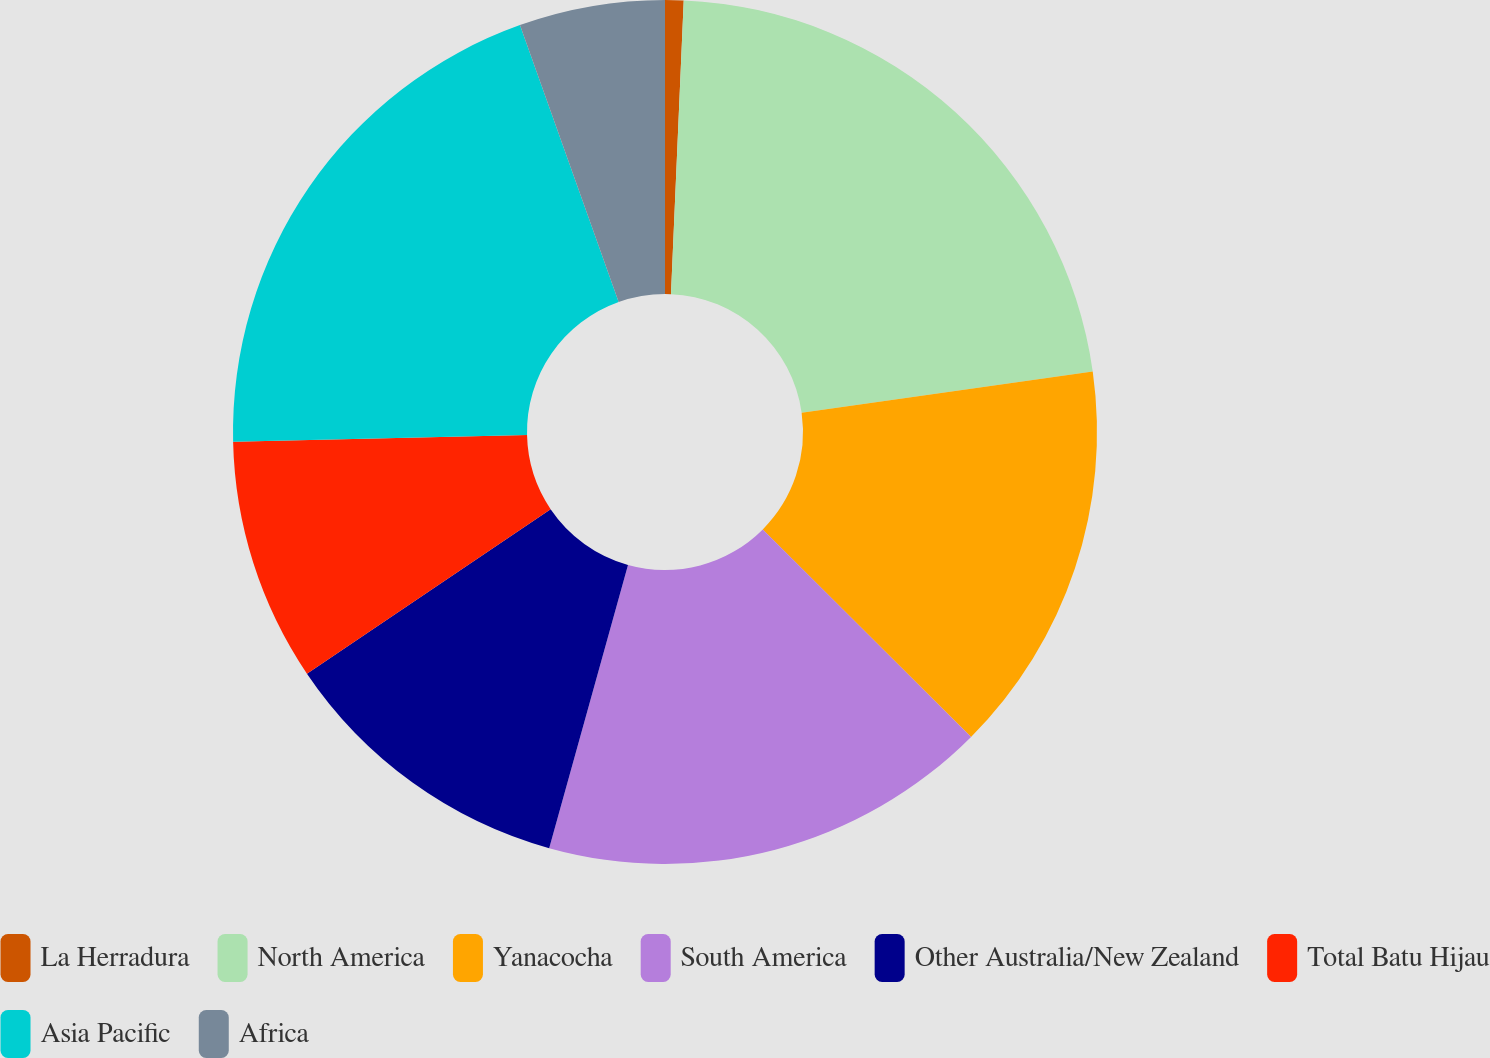Convert chart. <chart><loc_0><loc_0><loc_500><loc_500><pie_chart><fcel>La Herradura<fcel>North America<fcel>Yanacocha<fcel>South America<fcel>Other Australia/New Zealand<fcel>Total Batu Hijau<fcel>Asia Pacific<fcel>Africa<nl><fcel>0.69%<fcel>22.07%<fcel>14.71%<fcel>16.85%<fcel>11.23%<fcel>9.09%<fcel>19.91%<fcel>5.45%<nl></chart> 